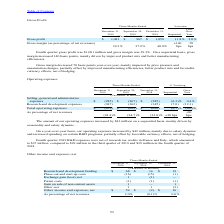According to Stmicroelectronics's financial document, Why did on sequential basis the operating expenses increased? driven by seasonality and salary dynamic.. The document states: "eased by $43 million on a sequential basis, mainly driven by seasonality and salary dynamic...." Also, Why did on year-over-year basis the operating expenses increased? mainly due to salary dynamic and increased spending on certain R&D programs, partially offset by favorable currency effects, net of hedging.. The document states: ", our operating expenses increased by $42 million, mainly due to salary dynamic and increased spending on certain R&D programs, partially offset by fa..." Also, How much did the R&D expenses account for in the fourth quarter of 2019? According to the financial document, $37 million. The relevant text states: "tax credits in France and Italy, which amounted to $37 million, compared to $29 million in the third quarter of 2019 and $39 million in the fourth quarter of 2018..." Also, can you calculate: What is the average Selling, general and administrative expenses for the period December 31, 2019 and September 29, 2019? To answer this question, I need to perform calculations using the financial data. The calculation is: (285+267) / 2, which equals 276 (in millions). This is based on the information: "g, general and administrative expenses $ (285) $ (267) $ (285) (6.3)% 0.4% Selling, general and administrative expenses $ (285) $ (267) $ (285) (6.3)% 0.4%..." The key data points involved are: 267, 285. Also, can you calculate: What is the average Research and development expenses for the period December 31, 2019 and 2018? To answer this question, I need to perform calculations using the financial data. The calculation is: (387+345) / 2, which equals 366 (in millions). This is based on the information: "Research and development expenses (387) (362) (345) (7.0) (12.3) Research and development expenses (387) (362) (345) (7.0) (12.3)..." The key data points involved are: 345, 387. Also, can you calculate: What is the increase/ (decrease) in total operating expenses from the period December 31, 2018 to 2019? Based on the calculation: 672-630, the result is 42 (in millions). This is based on the information: "Total operating expenses $ (672) $ (629) $ (630) (6.7)% (6.6)% Total operating expenses $ (672) $ (629) $ (630) (6.7)% (6.6)%..." The key data points involved are: 630, 672. 